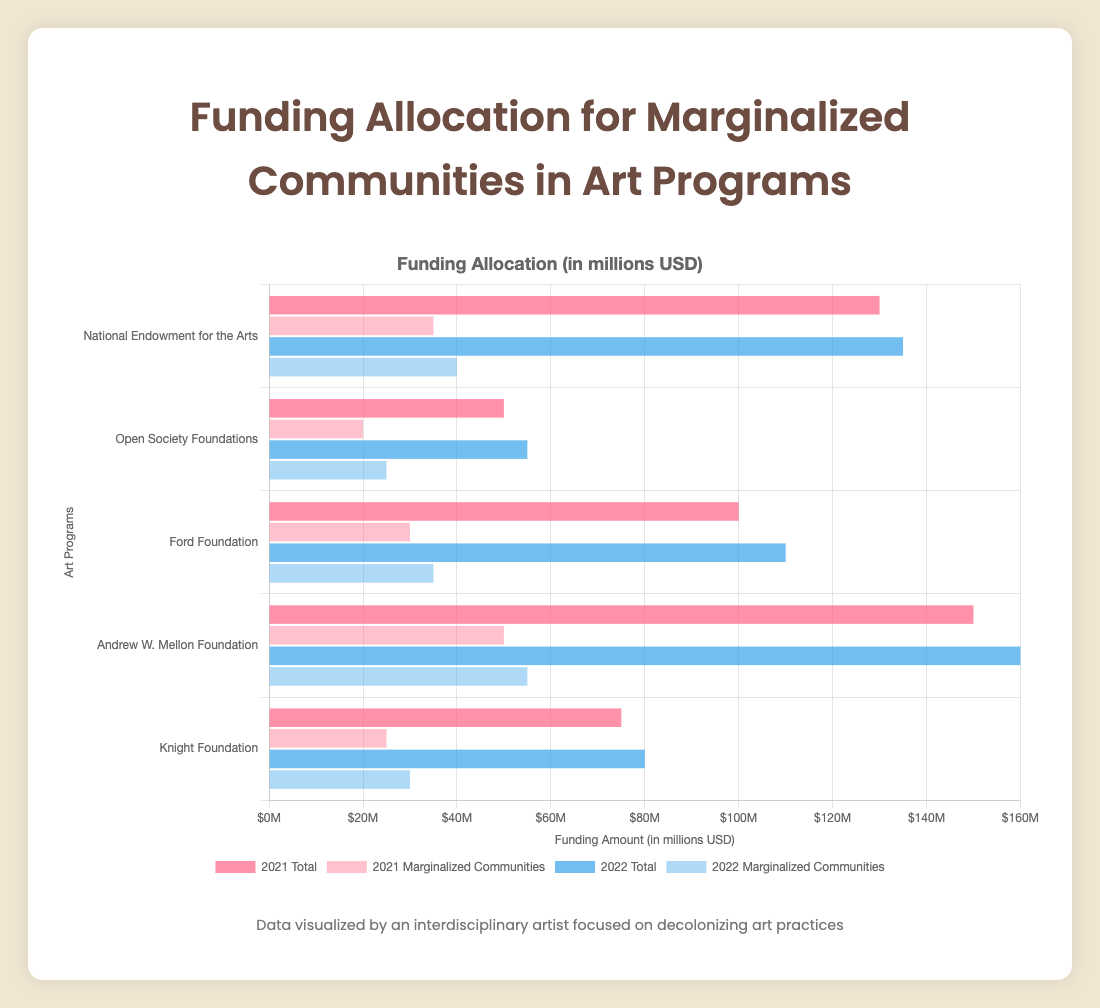Which program allocated the most total funding in 2022? Look at the bars representing total funding in 2022 for each program. The bar for the Andrew W. Mellon Foundation is the highest.
Answer: Andrew W. Mellon Foundation How much more funding was allocated to marginalized communities by the Ford Foundation in 2022 compared to 2021? Subtract the 2021 funding for marginalized communities by the Ford Foundation from the 2022 amount: $35,000,000 (2022) - $30,000,000 (2021).
Answer: $5,000,000 What is the average total funding for Open Society Foundations across 2021 and 2022? Add the total funding for 2021 and 2022, then divide by 2: ($50,000,000 + $55,000,000) / 2.
Answer: $52,500,000 Compare the percentage of funding allocated to marginalized communities by the Knight Foundation in 2021 and 2022. In which year did they allocate a higher percentage? Calculate the percentage for each year: (2021) 25,000,000 / 75,000,000 * 100 = 33.33%, (2022) 30,000,000 / 80,000,000 * 100 = 37.5%. Compare the results.
Answer: 2022 By how much did the National Endowment for the Arts increase its total funding from 2021 to 2022? Subtract the 2021 total funding from the 2022 total funding: $135,000,000 - $130,000,000.
Answer: $5,000,000 Which program allocated the least amount of funding to marginalized communities in 2021? Look at the bars representing funding for marginalized communities in 2021 for each program. The bar for Open Society Foundations is the shortest.
Answer: Open Society Foundations Which two programs had the same amount of funding for marginalized communities in 2022? Compare bars for marginalized communities in 2022; both National Endowment for the Arts and Ford Foundation have $40,000,000 and $35,000,000 respectively. However, Knight Foundation with $30,000,000 is noticeably different. No two programs allocated the same amount in 2022.
Answer: None How does the total funding for marginalized communities compare between the Ford Foundation and Andrew W. Mellon Foundation in 2022? Check the bars for 2022 funding for marginalized communities: Andrew W. Mellon Foundation ($55,000,000) is greater than Ford Foundation ($35,000,000).
Answer: Andrew W. Mellon Foundation What is the total funding amount for marginalized communities across all programs in 2021? Sum the 2021 funding for marginalized communities for each program: $35,000,000 (National Endowment for the Arts) + $20,000,000 (Open Society Foundations) + $30,000,000 (Ford Foundation) + $50,000,000 (Andrew W. Mellon Foundation) + $25,000,000 (Knight Foundation).
Answer: $160,000,000 